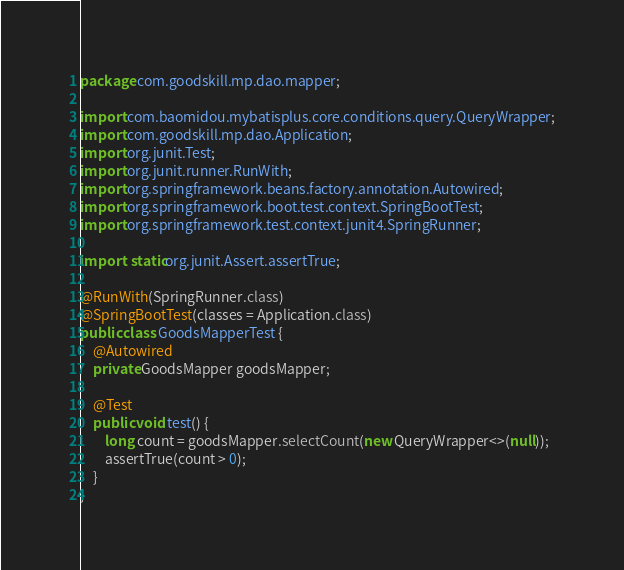Convert code to text. <code><loc_0><loc_0><loc_500><loc_500><_Java_>package com.goodskill.mp.dao.mapper;

import com.baomidou.mybatisplus.core.conditions.query.QueryWrapper;
import com.goodskill.mp.dao.Application;
import org.junit.Test;
import org.junit.runner.RunWith;
import org.springframework.beans.factory.annotation.Autowired;
import org.springframework.boot.test.context.SpringBootTest;
import org.springframework.test.context.junit4.SpringRunner;

import static org.junit.Assert.assertTrue;

@RunWith(SpringRunner.class)
@SpringBootTest(classes = Application.class)
public class GoodsMapperTest {
    @Autowired
    private GoodsMapper goodsMapper;

    @Test
    public void test() {
        long count = goodsMapper.selectCount(new QueryWrapper<>(null));
        assertTrue(count > 0);
    }
}</code> 